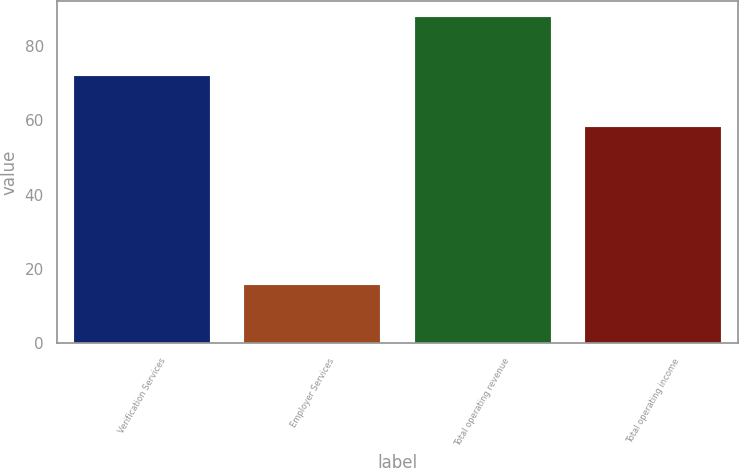Convert chart. <chart><loc_0><loc_0><loc_500><loc_500><bar_chart><fcel>Verification Services<fcel>Employer Services<fcel>Total operating revenue<fcel>Total operating income<nl><fcel>71.8<fcel>15.8<fcel>87.6<fcel>58.1<nl></chart> 